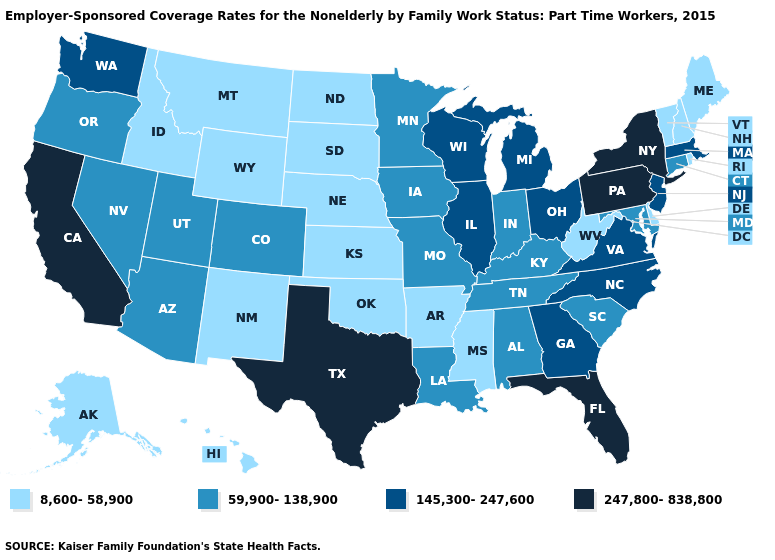Which states have the lowest value in the Northeast?
Answer briefly. Maine, New Hampshire, Rhode Island, Vermont. What is the value of Wisconsin?
Short answer required. 145,300-247,600. Does Arkansas have the lowest value in the USA?
Give a very brief answer. Yes. What is the value of Illinois?
Keep it brief. 145,300-247,600. Name the states that have a value in the range 8,600-58,900?
Concise answer only. Alaska, Arkansas, Delaware, Hawaii, Idaho, Kansas, Maine, Mississippi, Montana, Nebraska, New Hampshire, New Mexico, North Dakota, Oklahoma, Rhode Island, South Dakota, Vermont, West Virginia, Wyoming. Which states have the lowest value in the USA?
Quick response, please. Alaska, Arkansas, Delaware, Hawaii, Idaho, Kansas, Maine, Mississippi, Montana, Nebraska, New Hampshire, New Mexico, North Dakota, Oklahoma, Rhode Island, South Dakota, Vermont, West Virginia, Wyoming. Among the states that border Vermont , does New Hampshire have the lowest value?
Be succinct. Yes. How many symbols are there in the legend?
Quick response, please. 4. Does West Virginia have the lowest value in the South?
Give a very brief answer. Yes. What is the value of South Carolina?
Concise answer only. 59,900-138,900. What is the value of Colorado?
Be succinct. 59,900-138,900. Is the legend a continuous bar?
Write a very short answer. No. Name the states that have a value in the range 8,600-58,900?
Give a very brief answer. Alaska, Arkansas, Delaware, Hawaii, Idaho, Kansas, Maine, Mississippi, Montana, Nebraska, New Hampshire, New Mexico, North Dakota, Oklahoma, Rhode Island, South Dakota, Vermont, West Virginia, Wyoming. Does Louisiana have the lowest value in the South?
Answer briefly. No. 